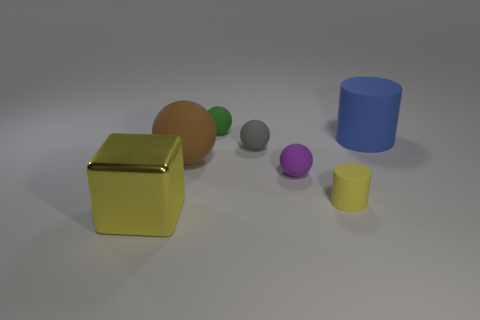Subtract all purple cubes. Subtract all cyan spheres. How many cubes are left? 1 Subtract all red cylinders. How many green cubes are left? 0 Add 4 blues. How many tiny purples exist? 0 Subtract all tiny gray matte balls. Subtract all purple objects. How many objects are left? 5 Add 5 tiny purple matte spheres. How many tiny purple matte spheres are left? 6 Add 3 yellow shiny objects. How many yellow shiny objects exist? 4 Add 2 gray rubber spheres. How many objects exist? 9 Subtract all blue cylinders. How many cylinders are left? 1 Subtract all large balls. How many balls are left? 3 Subtract 1 gray spheres. How many objects are left? 6 